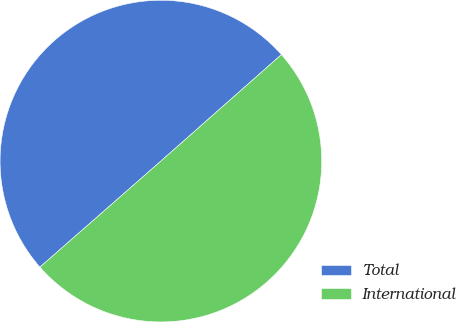Convert chart. <chart><loc_0><loc_0><loc_500><loc_500><pie_chart><fcel>Total<fcel>International<nl><fcel>49.94%<fcel>50.06%<nl></chart> 